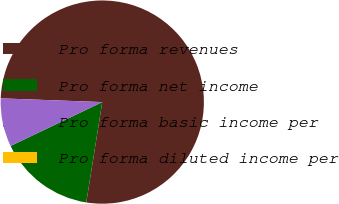<chart> <loc_0><loc_0><loc_500><loc_500><pie_chart><fcel>Pro forma revenues<fcel>Pro forma net income<fcel>Pro forma basic income per<fcel>Pro forma diluted income per<nl><fcel>76.92%<fcel>15.38%<fcel>7.69%<fcel>0.0%<nl></chart> 